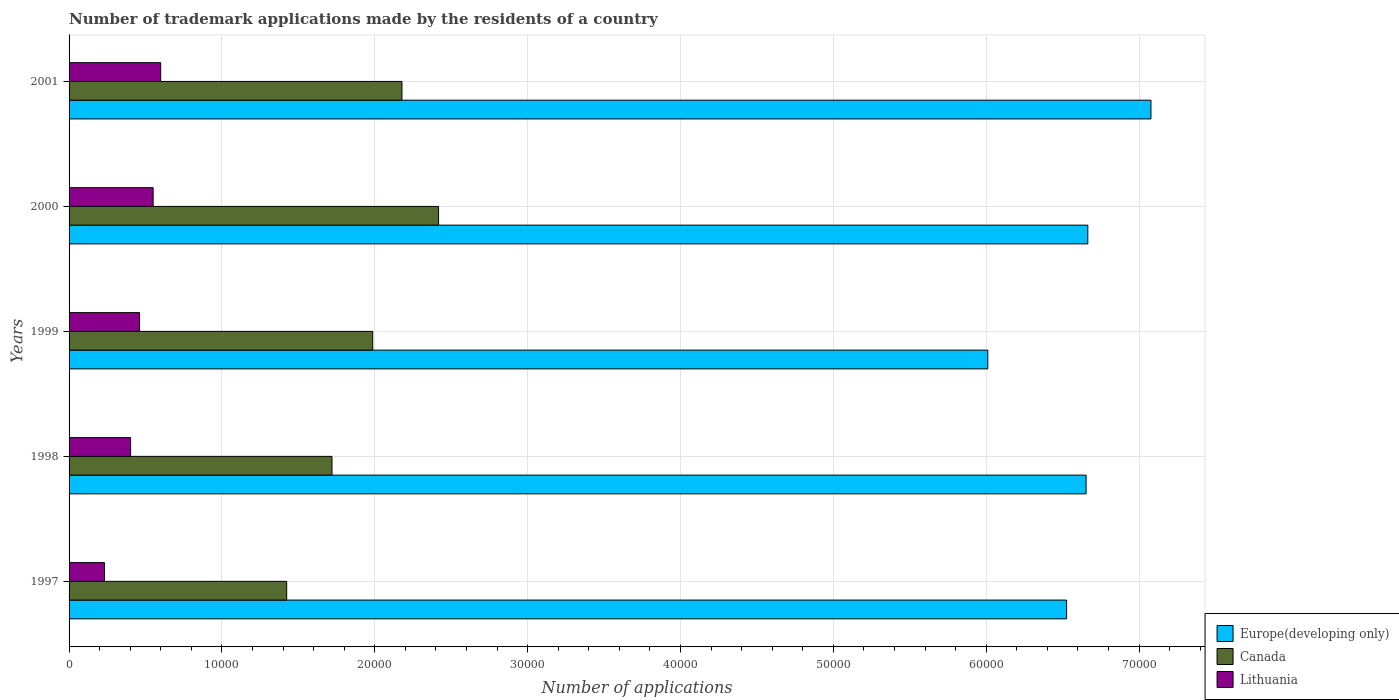How many different coloured bars are there?
Ensure brevity in your answer.  3. How many groups of bars are there?
Provide a succinct answer. 5. Are the number of bars per tick equal to the number of legend labels?
Your answer should be very brief. Yes. How many bars are there on the 3rd tick from the bottom?
Provide a short and direct response. 3. In how many cases, is the number of bars for a given year not equal to the number of legend labels?
Offer a terse response. 0. What is the number of trademark applications made by the residents in Europe(developing only) in 1999?
Your response must be concise. 6.01e+04. Across all years, what is the maximum number of trademark applications made by the residents in Canada?
Ensure brevity in your answer.  2.42e+04. Across all years, what is the minimum number of trademark applications made by the residents in Europe(developing only)?
Ensure brevity in your answer.  6.01e+04. What is the total number of trademark applications made by the residents in Europe(developing only) in the graph?
Provide a succinct answer. 3.29e+05. What is the difference between the number of trademark applications made by the residents in Canada in 2000 and that in 2001?
Provide a short and direct response. 2394. What is the difference between the number of trademark applications made by the residents in Lithuania in 2000 and the number of trademark applications made by the residents in Europe(developing only) in 1999?
Provide a succinct answer. -5.46e+04. What is the average number of trademark applications made by the residents in Lithuania per year?
Provide a succinct answer. 4489.4. In the year 2000, what is the difference between the number of trademark applications made by the residents in Canada and number of trademark applications made by the residents in Europe(developing only)?
Give a very brief answer. -4.25e+04. In how many years, is the number of trademark applications made by the residents in Europe(developing only) greater than 32000 ?
Keep it short and to the point. 5. What is the ratio of the number of trademark applications made by the residents in Europe(developing only) in 2000 to that in 2001?
Keep it short and to the point. 0.94. Is the number of trademark applications made by the residents in Lithuania in 1997 less than that in 2001?
Provide a succinct answer. Yes. Is the difference between the number of trademark applications made by the residents in Canada in 1999 and 2001 greater than the difference between the number of trademark applications made by the residents in Europe(developing only) in 1999 and 2001?
Keep it short and to the point. Yes. What is the difference between the highest and the second highest number of trademark applications made by the residents in Canada?
Your answer should be compact. 2394. What is the difference between the highest and the lowest number of trademark applications made by the residents in Canada?
Ensure brevity in your answer.  9935. Is the sum of the number of trademark applications made by the residents in Lithuania in 1998 and 2000 greater than the maximum number of trademark applications made by the residents in Europe(developing only) across all years?
Make the answer very short. No. What does the 2nd bar from the top in 1997 represents?
Offer a terse response. Canada. What does the 1st bar from the bottom in 2000 represents?
Provide a short and direct response. Europe(developing only). Are all the bars in the graph horizontal?
Offer a terse response. Yes. How many years are there in the graph?
Your answer should be compact. 5. Are the values on the major ticks of X-axis written in scientific E-notation?
Give a very brief answer. No. Does the graph contain any zero values?
Keep it short and to the point. No. Does the graph contain grids?
Offer a terse response. Yes. Where does the legend appear in the graph?
Offer a very short reply. Bottom right. How are the legend labels stacked?
Your answer should be compact. Vertical. What is the title of the graph?
Ensure brevity in your answer.  Number of trademark applications made by the residents of a country. Does "Cote d'Ivoire" appear as one of the legend labels in the graph?
Offer a terse response. No. What is the label or title of the X-axis?
Your response must be concise. Number of applications. What is the Number of applications of Europe(developing only) in 1997?
Ensure brevity in your answer.  6.53e+04. What is the Number of applications of Canada in 1997?
Keep it short and to the point. 1.42e+04. What is the Number of applications in Lithuania in 1997?
Your answer should be very brief. 2316. What is the Number of applications of Europe(developing only) in 1998?
Your answer should be very brief. 6.65e+04. What is the Number of applications of Canada in 1998?
Your response must be concise. 1.72e+04. What is the Number of applications of Lithuania in 1998?
Keep it short and to the point. 4025. What is the Number of applications of Europe(developing only) in 1999?
Keep it short and to the point. 6.01e+04. What is the Number of applications in Canada in 1999?
Provide a short and direct response. 1.99e+04. What is the Number of applications in Lithuania in 1999?
Provide a succinct answer. 4612. What is the Number of applications in Europe(developing only) in 2000?
Your answer should be very brief. 6.66e+04. What is the Number of applications of Canada in 2000?
Give a very brief answer. 2.42e+04. What is the Number of applications in Lithuania in 2000?
Make the answer very short. 5500. What is the Number of applications of Europe(developing only) in 2001?
Provide a short and direct response. 7.08e+04. What is the Number of applications of Canada in 2001?
Give a very brief answer. 2.18e+04. What is the Number of applications in Lithuania in 2001?
Provide a succinct answer. 5994. Across all years, what is the maximum Number of applications in Europe(developing only)?
Your answer should be very brief. 7.08e+04. Across all years, what is the maximum Number of applications in Canada?
Provide a succinct answer. 2.42e+04. Across all years, what is the maximum Number of applications of Lithuania?
Give a very brief answer. 5994. Across all years, what is the minimum Number of applications in Europe(developing only)?
Offer a very short reply. 6.01e+04. Across all years, what is the minimum Number of applications in Canada?
Your response must be concise. 1.42e+04. Across all years, what is the minimum Number of applications of Lithuania?
Offer a very short reply. 2316. What is the total Number of applications of Europe(developing only) in the graph?
Ensure brevity in your answer.  3.29e+05. What is the total Number of applications of Canada in the graph?
Ensure brevity in your answer.  9.73e+04. What is the total Number of applications in Lithuania in the graph?
Your response must be concise. 2.24e+04. What is the difference between the Number of applications of Europe(developing only) in 1997 and that in 1998?
Your response must be concise. -1273. What is the difference between the Number of applications of Canada in 1997 and that in 1998?
Provide a short and direct response. -2964. What is the difference between the Number of applications in Lithuania in 1997 and that in 1998?
Provide a short and direct response. -1709. What is the difference between the Number of applications of Europe(developing only) in 1997 and that in 1999?
Provide a succinct answer. 5156. What is the difference between the Number of applications in Canada in 1997 and that in 1999?
Your answer should be compact. -5626. What is the difference between the Number of applications of Lithuania in 1997 and that in 1999?
Ensure brevity in your answer.  -2296. What is the difference between the Number of applications of Europe(developing only) in 1997 and that in 2000?
Offer a terse response. -1387. What is the difference between the Number of applications of Canada in 1997 and that in 2000?
Give a very brief answer. -9935. What is the difference between the Number of applications in Lithuania in 1997 and that in 2000?
Your response must be concise. -3184. What is the difference between the Number of applications in Europe(developing only) in 1997 and that in 2001?
Give a very brief answer. -5518. What is the difference between the Number of applications in Canada in 1997 and that in 2001?
Offer a very short reply. -7541. What is the difference between the Number of applications of Lithuania in 1997 and that in 2001?
Give a very brief answer. -3678. What is the difference between the Number of applications of Europe(developing only) in 1998 and that in 1999?
Your response must be concise. 6429. What is the difference between the Number of applications of Canada in 1998 and that in 1999?
Your answer should be compact. -2662. What is the difference between the Number of applications of Lithuania in 1998 and that in 1999?
Provide a succinct answer. -587. What is the difference between the Number of applications in Europe(developing only) in 1998 and that in 2000?
Your answer should be compact. -114. What is the difference between the Number of applications in Canada in 1998 and that in 2000?
Give a very brief answer. -6971. What is the difference between the Number of applications in Lithuania in 1998 and that in 2000?
Give a very brief answer. -1475. What is the difference between the Number of applications in Europe(developing only) in 1998 and that in 2001?
Provide a short and direct response. -4245. What is the difference between the Number of applications of Canada in 1998 and that in 2001?
Provide a succinct answer. -4577. What is the difference between the Number of applications in Lithuania in 1998 and that in 2001?
Make the answer very short. -1969. What is the difference between the Number of applications in Europe(developing only) in 1999 and that in 2000?
Provide a succinct answer. -6543. What is the difference between the Number of applications of Canada in 1999 and that in 2000?
Keep it short and to the point. -4309. What is the difference between the Number of applications of Lithuania in 1999 and that in 2000?
Your response must be concise. -888. What is the difference between the Number of applications in Europe(developing only) in 1999 and that in 2001?
Provide a short and direct response. -1.07e+04. What is the difference between the Number of applications of Canada in 1999 and that in 2001?
Offer a very short reply. -1915. What is the difference between the Number of applications in Lithuania in 1999 and that in 2001?
Provide a succinct answer. -1382. What is the difference between the Number of applications in Europe(developing only) in 2000 and that in 2001?
Keep it short and to the point. -4131. What is the difference between the Number of applications of Canada in 2000 and that in 2001?
Make the answer very short. 2394. What is the difference between the Number of applications of Lithuania in 2000 and that in 2001?
Offer a very short reply. -494. What is the difference between the Number of applications in Europe(developing only) in 1997 and the Number of applications in Canada in 1998?
Make the answer very short. 4.81e+04. What is the difference between the Number of applications in Europe(developing only) in 1997 and the Number of applications in Lithuania in 1998?
Provide a succinct answer. 6.12e+04. What is the difference between the Number of applications of Canada in 1997 and the Number of applications of Lithuania in 1998?
Your answer should be compact. 1.02e+04. What is the difference between the Number of applications in Europe(developing only) in 1997 and the Number of applications in Canada in 1999?
Ensure brevity in your answer.  4.54e+04. What is the difference between the Number of applications of Europe(developing only) in 1997 and the Number of applications of Lithuania in 1999?
Your response must be concise. 6.06e+04. What is the difference between the Number of applications of Canada in 1997 and the Number of applications of Lithuania in 1999?
Your answer should be very brief. 9625. What is the difference between the Number of applications in Europe(developing only) in 1997 and the Number of applications in Canada in 2000?
Your answer should be very brief. 4.11e+04. What is the difference between the Number of applications in Europe(developing only) in 1997 and the Number of applications in Lithuania in 2000?
Give a very brief answer. 5.98e+04. What is the difference between the Number of applications of Canada in 1997 and the Number of applications of Lithuania in 2000?
Make the answer very short. 8737. What is the difference between the Number of applications in Europe(developing only) in 1997 and the Number of applications in Canada in 2001?
Your response must be concise. 4.35e+04. What is the difference between the Number of applications in Europe(developing only) in 1997 and the Number of applications in Lithuania in 2001?
Offer a terse response. 5.93e+04. What is the difference between the Number of applications of Canada in 1997 and the Number of applications of Lithuania in 2001?
Offer a very short reply. 8243. What is the difference between the Number of applications of Europe(developing only) in 1998 and the Number of applications of Canada in 1999?
Offer a terse response. 4.67e+04. What is the difference between the Number of applications of Europe(developing only) in 1998 and the Number of applications of Lithuania in 1999?
Make the answer very short. 6.19e+04. What is the difference between the Number of applications of Canada in 1998 and the Number of applications of Lithuania in 1999?
Provide a short and direct response. 1.26e+04. What is the difference between the Number of applications in Europe(developing only) in 1998 and the Number of applications in Canada in 2000?
Your answer should be compact. 4.24e+04. What is the difference between the Number of applications of Europe(developing only) in 1998 and the Number of applications of Lithuania in 2000?
Offer a very short reply. 6.10e+04. What is the difference between the Number of applications of Canada in 1998 and the Number of applications of Lithuania in 2000?
Your response must be concise. 1.17e+04. What is the difference between the Number of applications of Europe(developing only) in 1998 and the Number of applications of Canada in 2001?
Offer a terse response. 4.48e+04. What is the difference between the Number of applications in Europe(developing only) in 1998 and the Number of applications in Lithuania in 2001?
Your response must be concise. 6.05e+04. What is the difference between the Number of applications of Canada in 1998 and the Number of applications of Lithuania in 2001?
Provide a succinct answer. 1.12e+04. What is the difference between the Number of applications of Europe(developing only) in 1999 and the Number of applications of Canada in 2000?
Give a very brief answer. 3.59e+04. What is the difference between the Number of applications in Europe(developing only) in 1999 and the Number of applications in Lithuania in 2000?
Offer a terse response. 5.46e+04. What is the difference between the Number of applications in Canada in 1999 and the Number of applications in Lithuania in 2000?
Make the answer very short. 1.44e+04. What is the difference between the Number of applications of Europe(developing only) in 1999 and the Number of applications of Canada in 2001?
Your response must be concise. 3.83e+04. What is the difference between the Number of applications of Europe(developing only) in 1999 and the Number of applications of Lithuania in 2001?
Ensure brevity in your answer.  5.41e+04. What is the difference between the Number of applications in Canada in 1999 and the Number of applications in Lithuania in 2001?
Provide a succinct answer. 1.39e+04. What is the difference between the Number of applications of Europe(developing only) in 2000 and the Number of applications of Canada in 2001?
Your answer should be compact. 4.49e+04. What is the difference between the Number of applications in Europe(developing only) in 2000 and the Number of applications in Lithuania in 2001?
Offer a very short reply. 6.07e+04. What is the difference between the Number of applications of Canada in 2000 and the Number of applications of Lithuania in 2001?
Provide a succinct answer. 1.82e+04. What is the average Number of applications of Europe(developing only) per year?
Offer a terse response. 6.59e+04. What is the average Number of applications in Canada per year?
Your response must be concise. 1.95e+04. What is the average Number of applications of Lithuania per year?
Provide a short and direct response. 4489.4. In the year 1997, what is the difference between the Number of applications in Europe(developing only) and Number of applications in Canada?
Offer a terse response. 5.10e+04. In the year 1997, what is the difference between the Number of applications in Europe(developing only) and Number of applications in Lithuania?
Your answer should be very brief. 6.29e+04. In the year 1997, what is the difference between the Number of applications of Canada and Number of applications of Lithuania?
Your answer should be compact. 1.19e+04. In the year 1998, what is the difference between the Number of applications of Europe(developing only) and Number of applications of Canada?
Provide a short and direct response. 4.93e+04. In the year 1998, what is the difference between the Number of applications in Europe(developing only) and Number of applications in Lithuania?
Ensure brevity in your answer.  6.25e+04. In the year 1998, what is the difference between the Number of applications of Canada and Number of applications of Lithuania?
Provide a short and direct response. 1.32e+04. In the year 1999, what is the difference between the Number of applications in Europe(developing only) and Number of applications in Canada?
Provide a short and direct response. 4.02e+04. In the year 1999, what is the difference between the Number of applications of Europe(developing only) and Number of applications of Lithuania?
Keep it short and to the point. 5.55e+04. In the year 1999, what is the difference between the Number of applications in Canada and Number of applications in Lithuania?
Ensure brevity in your answer.  1.53e+04. In the year 2000, what is the difference between the Number of applications of Europe(developing only) and Number of applications of Canada?
Your answer should be very brief. 4.25e+04. In the year 2000, what is the difference between the Number of applications of Europe(developing only) and Number of applications of Lithuania?
Offer a terse response. 6.11e+04. In the year 2000, what is the difference between the Number of applications of Canada and Number of applications of Lithuania?
Keep it short and to the point. 1.87e+04. In the year 2001, what is the difference between the Number of applications of Europe(developing only) and Number of applications of Canada?
Ensure brevity in your answer.  4.90e+04. In the year 2001, what is the difference between the Number of applications in Europe(developing only) and Number of applications in Lithuania?
Provide a succinct answer. 6.48e+04. In the year 2001, what is the difference between the Number of applications of Canada and Number of applications of Lithuania?
Your answer should be compact. 1.58e+04. What is the ratio of the Number of applications of Europe(developing only) in 1997 to that in 1998?
Provide a succinct answer. 0.98. What is the ratio of the Number of applications in Canada in 1997 to that in 1998?
Offer a terse response. 0.83. What is the ratio of the Number of applications of Lithuania in 1997 to that in 1998?
Make the answer very short. 0.58. What is the ratio of the Number of applications of Europe(developing only) in 1997 to that in 1999?
Provide a succinct answer. 1.09. What is the ratio of the Number of applications in Canada in 1997 to that in 1999?
Offer a terse response. 0.72. What is the ratio of the Number of applications of Lithuania in 1997 to that in 1999?
Your response must be concise. 0.5. What is the ratio of the Number of applications of Europe(developing only) in 1997 to that in 2000?
Your response must be concise. 0.98. What is the ratio of the Number of applications in Canada in 1997 to that in 2000?
Offer a terse response. 0.59. What is the ratio of the Number of applications of Lithuania in 1997 to that in 2000?
Give a very brief answer. 0.42. What is the ratio of the Number of applications in Europe(developing only) in 1997 to that in 2001?
Make the answer very short. 0.92. What is the ratio of the Number of applications in Canada in 1997 to that in 2001?
Your response must be concise. 0.65. What is the ratio of the Number of applications of Lithuania in 1997 to that in 2001?
Make the answer very short. 0.39. What is the ratio of the Number of applications in Europe(developing only) in 1998 to that in 1999?
Provide a succinct answer. 1.11. What is the ratio of the Number of applications of Canada in 1998 to that in 1999?
Give a very brief answer. 0.87. What is the ratio of the Number of applications of Lithuania in 1998 to that in 1999?
Ensure brevity in your answer.  0.87. What is the ratio of the Number of applications of Europe(developing only) in 1998 to that in 2000?
Give a very brief answer. 1. What is the ratio of the Number of applications in Canada in 1998 to that in 2000?
Make the answer very short. 0.71. What is the ratio of the Number of applications of Lithuania in 1998 to that in 2000?
Keep it short and to the point. 0.73. What is the ratio of the Number of applications in Canada in 1998 to that in 2001?
Provide a short and direct response. 0.79. What is the ratio of the Number of applications in Lithuania in 1998 to that in 2001?
Keep it short and to the point. 0.67. What is the ratio of the Number of applications in Europe(developing only) in 1999 to that in 2000?
Offer a very short reply. 0.9. What is the ratio of the Number of applications of Canada in 1999 to that in 2000?
Your answer should be very brief. 0.82. What is the ratio of the Number of applications in Lithuania in 1999 to that in 2000?
Give a very brief answer. 0.84. What is the ratio of the Number of applications of Europe(developing only) in 1999 to that in 2001?
Make the answer very short. 0.85. What is the ratio of the Number of applications in Canada in 1999 to that in 2001?
Provide a short and direct response. 0.91. What is the ratio of the Number of applications in Lithuania in 1999 to that in 2001?
Your response must be concise. 0.77. What is the ratio of the Number of applications in Europe(developing only) in 2000 to that in 2001?
Offer a very short reply. 0.94. What is the ratio of the Number of applications of Canada in 2000 to that in 2001?
Give a very brief answer. 1.11. What is the ratio of the Number of applications in Lithuania in 2000 to that in 2001?
Make the answer very short. 0.92. What is the difference between the highest and the second highest Number of applications of Europe(developing only)?
Give a very brief answer. 4131. What is the difference between the highest and the second highest Number of applications in Canada?
Provide a short and direct response. 2394. What is the difference between the highest and the second highest Number of applications of Lithuania?
Your answer should be compact. 494. What is the difference between the highest and the lowest Number of applications of Europe(developing only)?
Keep it short and to the point. 1.07e+04. What is the difference between the highest and the lowest Number of applications in Canada?
Your answer should be compact. 9935. What is the difference between the highest and the lowest Number of applications of Lithuania?
Ensure brevity in your answer.  3678. 